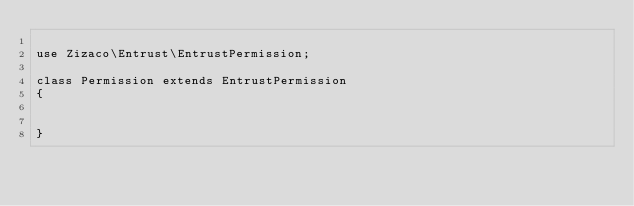<code> <loc_0><loc_0><loc_500><loc_500><_PHP_>
use Zizaco\Entrust\EntrustPermission;

class Permission extends EntrustPermission
{


}</code> 